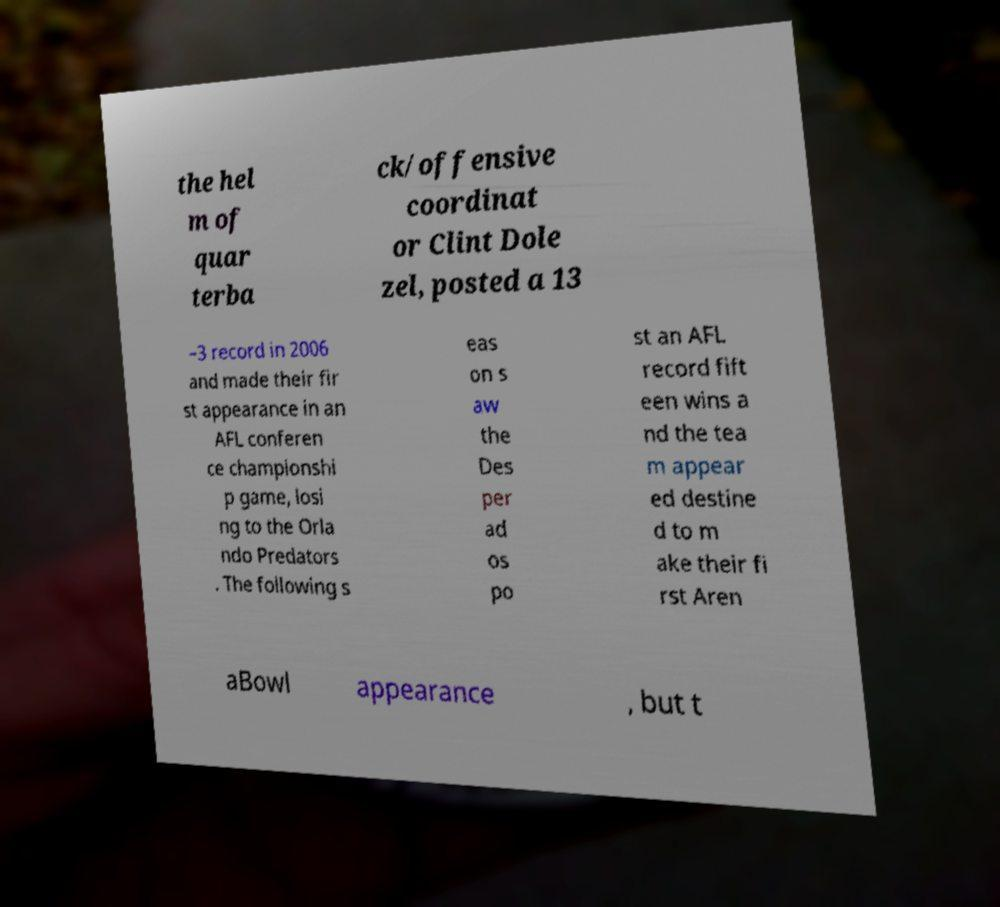Can you accurately transcribe the text from the provided image for me? the hel m of quar terba ck/offensive coordinat or Clint Dole zel, posted a 13 –3 record in 2006 and made their fir st appearance in an AFL conferen ce championshi p game, losi ng to the Orla ndo Predators . The following s eas on s aw the Des per ad os po st an AFL record fift een wins a nd the tea m appear ed destine d to m ake their fi rst Aren aBowl appearance , but t 